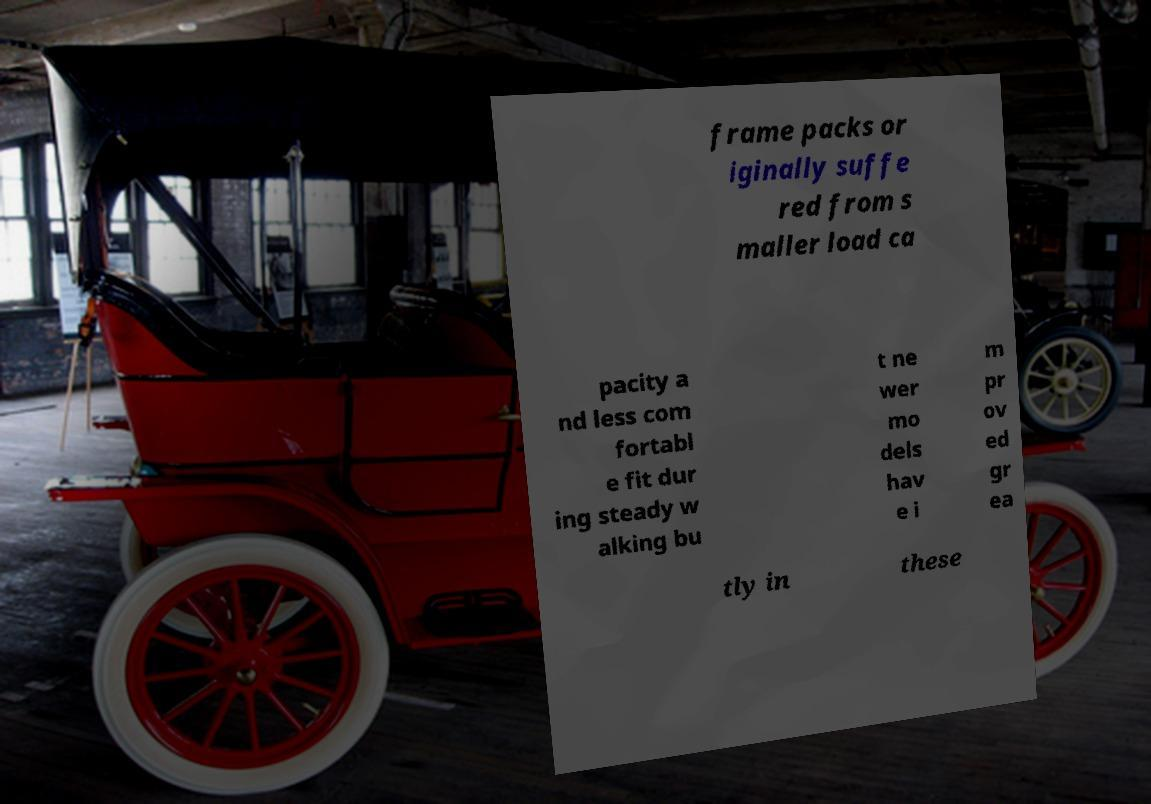Could you extract and type out the text from this image? frame packs or iginally suffe red from s maller load ca pacity a nd less com fortabl e fit dur ing steady w alking bu t ne wer mo dels hav e i m pr ov ed gr ea tly in these 